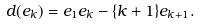Convert formula to latex. <formula><loc_0><loc_0><loc_500><loc_500>d ( e _ { k } ) = e _ { 1 } e _ { k } - \{ k + 1 \} e _ { k + 1 } .</formula> 